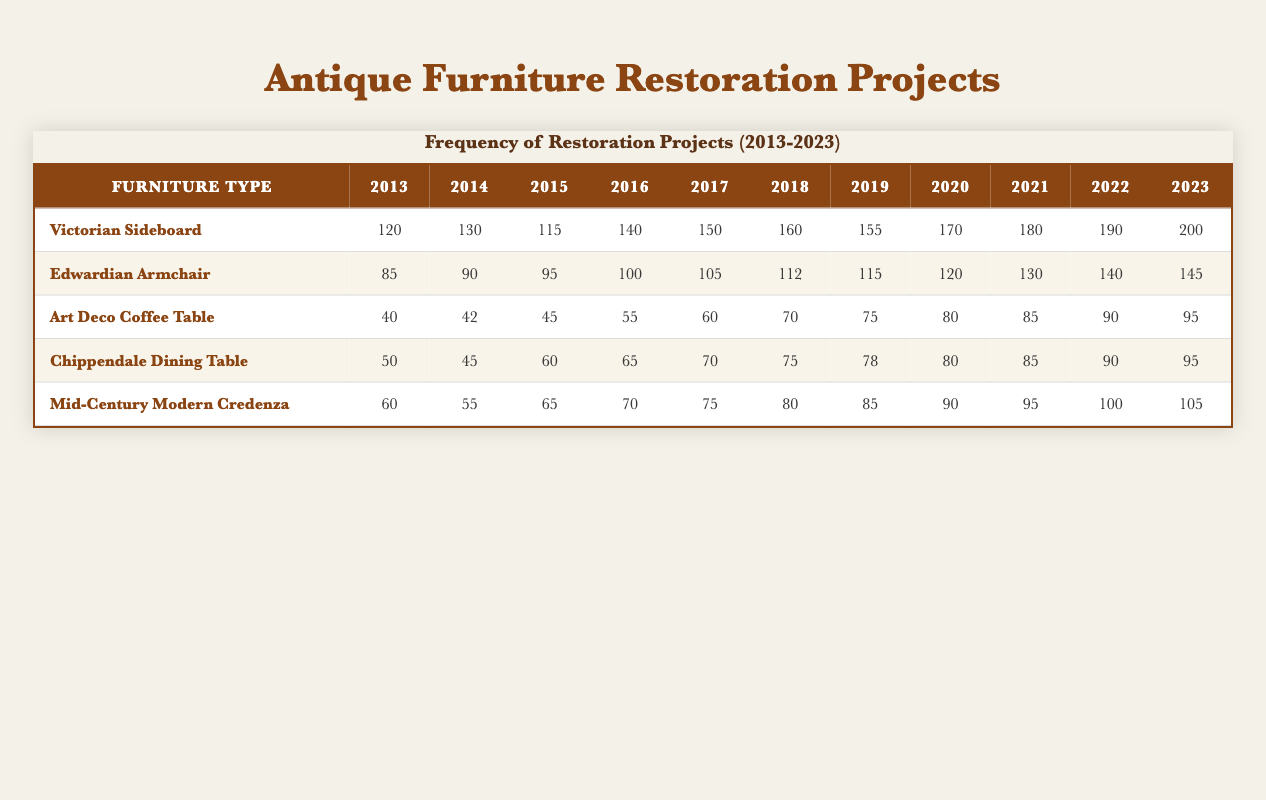What was the maximum number of restoration projects undertaken for the Victorian Sideboard? From the table, the number of restoration projects for the Victorian Sideboard peaked at 200 in 2023.
Answer: 200 How many restoration projects were completed for the Edwardian Armchair in 2017? The table shows that there were 105 restoration projects undertaken for the Edwardian Armchair in 2017.
Answer: 105 Which type of antique furniture had the fewest restoration projects in 2013? In 2013, the Art Deco Coffee Table had the fewest restoration projects, with only 40 projects compared to others.
Answer: Art Deco Coffee Table What is the total number of restoration projects for the Chippendale Dining Table over the last decade? Summing the years 2013 to 2023 for the Chippendale Dining Table gives (50 + 45 + 60 + 65 + 70 + 75 + 78 + 80 + 85 + 90 + 95) =  850.
Answer: 850 Did the number of restoration projects for the Mid-Century Modern Credenza increase every year? A review of the data shows that the numbers increased each year from 2013 to 2023, confirming the increase yearly.
Answer: Yes What was the average number of restoration projects for the Art Deco Coffee Table from 2013 to 2023? The total for the Art Deco Coffee Table is (40 + 42 + 45 + 55 + 60 + 70 + 75 + 80 + 85 + 90 + 95) =  792. Dividing this by 11 years results in an average of 72.
Answer: 72 Which type of antique furniture had the highest total restoration projects from 2013 to 2023? The total projects for each type are calculated as follows: Victorian Sideboard = 1,570, Edwardian Armchair = 1,425, Art Deco Coffee Table = 792, Chippendale Dining Table = 850, and Mid-Century Modern Credenza =  1,015. The Victorian Sideboard had the highest at 1,570.
Answer: Victorian Sideboard What percentage increase in restoration projects did the Victorian Sideboard experience from 2013 to 2023? The increase from 120 in 2013 to 200 in 2023 is a difference of 80. The percentage increase is (80/120) * 100 = 66.67%.
Answer: 66.67% How did the restoration projects for the Mid-Century Modern Credenza in 2020 compare to those in 2013? The Mid-Century Modern Credenza had 90 in 2020 and 60 in 2013, indicating an increase of 30 projects from 2013 to 2020.
Answer: Increased by 30 